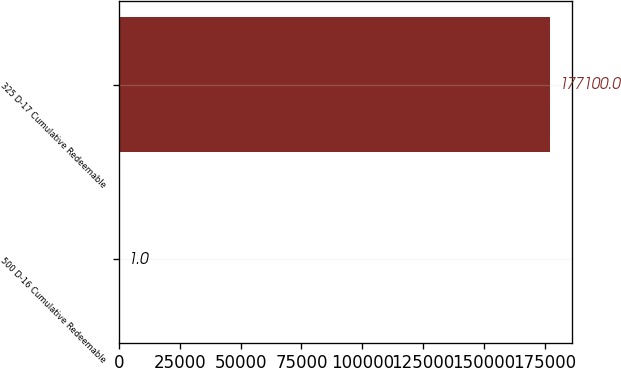Convert chart to OTSL. <chart><loc_0><loc_0><loc_500><loc_500><bar_chart><fcel>500 D-16 Cumulative Redeemable<fcel>325 D-17 Cumulative Redeemable<nl><fcel>1<fcel>177100<nl></chart> 